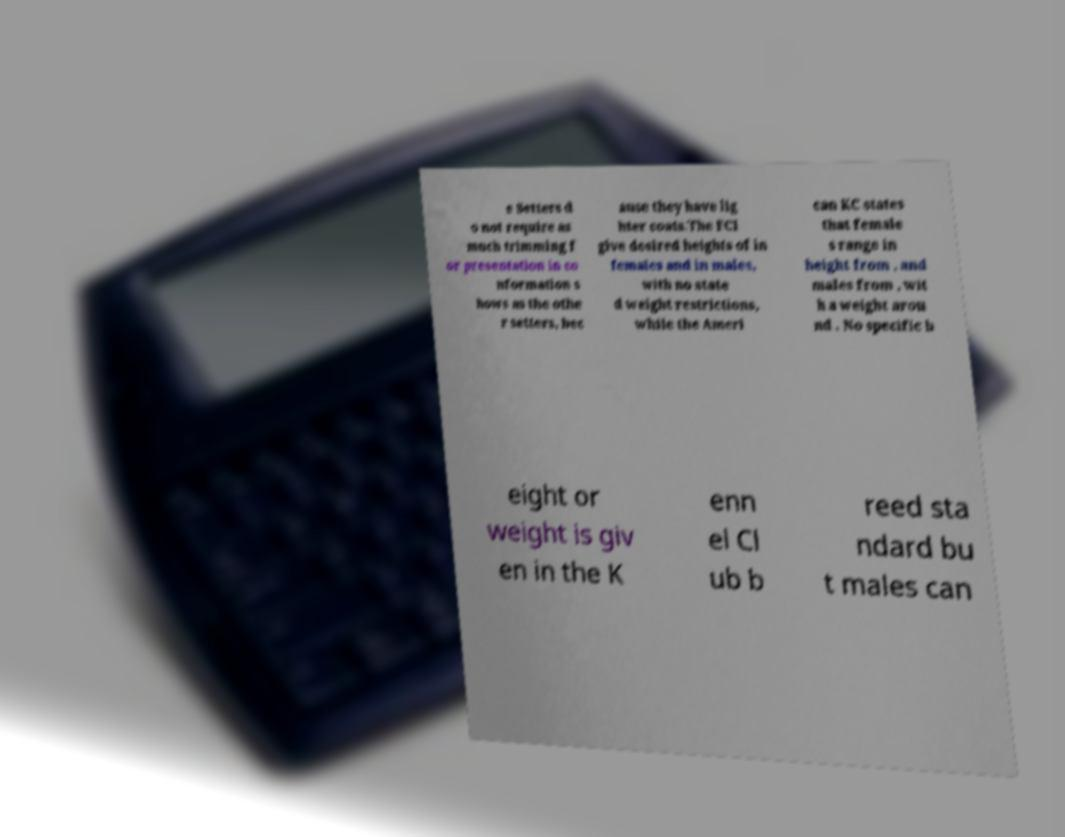Please identify and transcribe the text found in this image. e Setters d o not require as much trimming f or presentation in co nformation s hows as the othe r setters, bec ause they have lig hter coats.The FCI give desired heights of in females and in males, with no state d weight restrictions, while the Ameri can KC states that female s range in height from , and males from , wit h a weight arou nd . No specific h eight or weight is giv en in the K enn el Cl ub b reed sta ndard bu t males can 